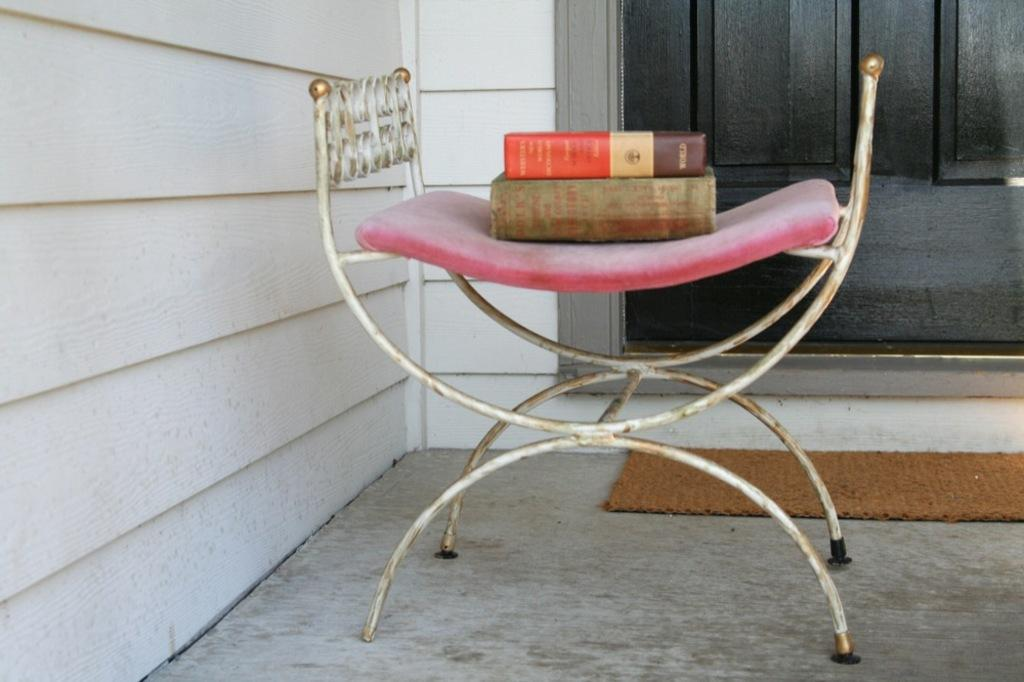What object is present in the image that can be used for sitting? There is a stool in the image that can be used for sitting. What is placed on the stool? There are books on the stool. What is on the floor in the image? There is a mat on the floor. What can be seen behind the stool? There is a door behind the stool. What is to the left of the stool? There is a wall to the left of the stool. How many kittens are sitting on the wall in the image? There are no kittens present in the image, and therefore no kittens can be seen sitting on the wall. 